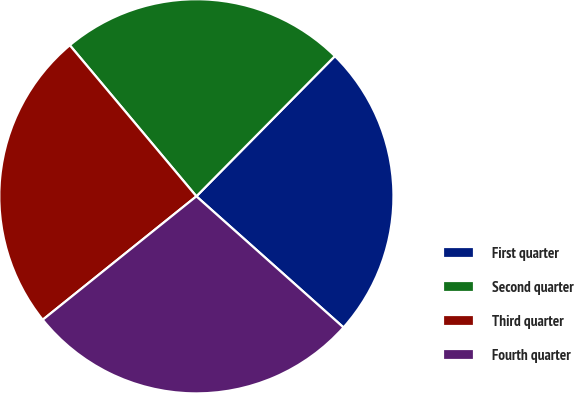Convert chart to OTSL. <chart><loc_0><loc_0><loc_500><loc_500><pie_chart><fcel>First quarter<fcel>Second quarter<fcel>Third quarter<fcel>Fourth quarter<nl><fcel>24.18%<fcel>23.5%<fcel>24.67%<fcel>27.64%<nl></chart> 